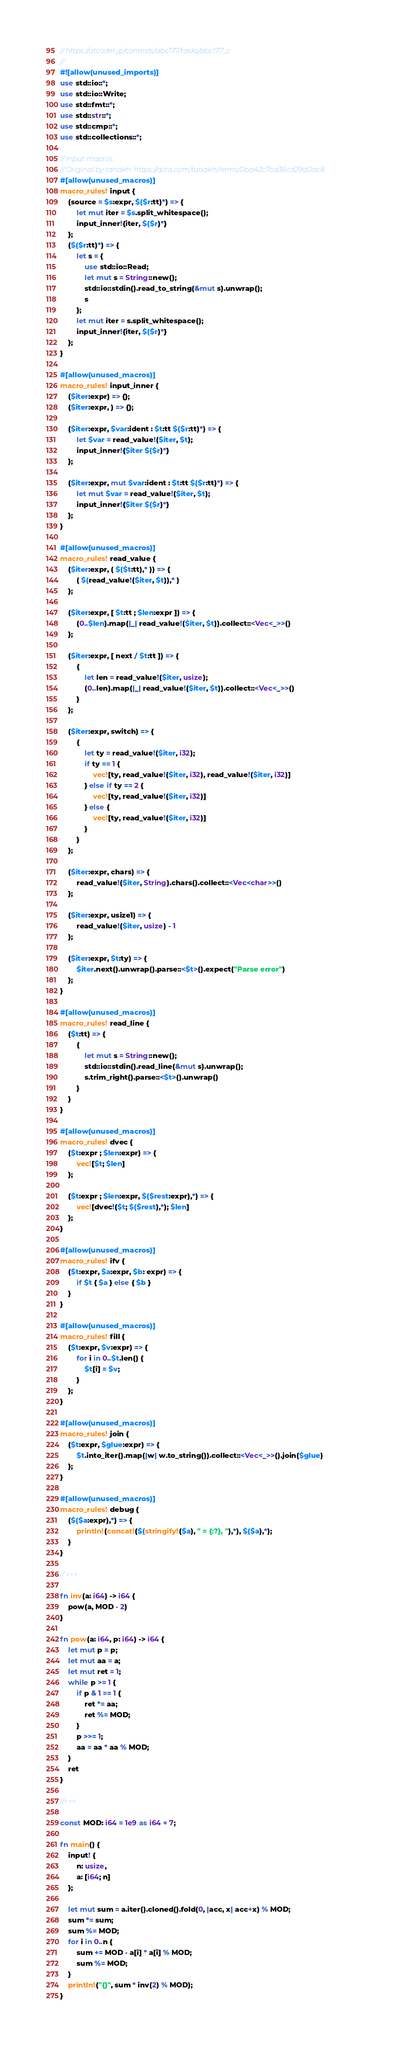Convert code to text. <code><loc_0><loc_0><loc_500><loc_500><_Rust_>// https://atcoder.jp/contests/abc177/tasks/abc177_c
//
#![allow(unused_imports)]
use std::io::*;
use std::io::Write;
use std::fmt::*;
use std::str::*;
use std::cmp::*;
use std::collections::*;

// Input macros.
// Original by tanakh: https://qiita.com/tanakh/items/0ba42c7ca36cd29d0ac8
#[allow(unused_macros)]
macro_rules! input {
    (source = $s:expr, $($r:tt)*) => {
        let mut iter = $s.split_whitespace();
        input_inner!{iter, $($r)*}
    };
    ($($r:tt)*) => {
        let s = {
            use std::io::Read;
            let mut s = String::new();
            std::io::stdin().read_to_string(&mut s).unwrap();
            s
        };
        let mut iter = s.split_whitespace();
        input_inner!{iter, $($r)*}
    };
}

#[allow(unused_macros)]
macro_rules! input_inner {
    ($iter:expr) => {};
    ($iter:expr, ) => {};

    ($iter:expr, $var:ident : $t:tt $($r:tt)*) => {
        let $var = read_value!($iter, $t);
        input_inner!{$iter $($r)*}
    };

    ($iter:expr, mut $var:ident : $t:tt $($r:tt)*) => {
        let mut $var = read_value!($iter, $t);
        input_inner!{$iter $($r)*}
    };
}

#[allow(unused_macros)]
macro_rules! read_value {
    ($iter:expr, ( $($t:tt),* )) => {
        ( $(read_value!($iter, $t)),* )
    };

    ($iter:expr, [ $t:tt ; $len:expr ]) => {
        (0..$len).map(|_| read_value!($iter, $t)).collect::<Vec<_>>()
    };

    ($iter:expr, [ next / $t:tt ]) => {
        {
            let len = read_value!($iter, usize);
            (0..len).map(|_| read_value!($iter, $t)).collect::<Vec<_>>()
        }
    };

    ($iter:expr, switch) => {
        {
            let ty = read_value!($iter, i32);
            if ty == 1 {
                vec![ty, read_value!($iter, i32), read_value!($iter, i32)]
            } else if ty == 2 {
                vec![ty, read_value!($iter, i32)]
            } else {
                vec![ty, read_value!($iter, i32)]
            }
        }
    };

    ($iter:expr, chars) => {
        read_value!($iter, String).chars().collect::<Vec<char>>()
    };

    ($iter:expr, usize1) => {
        read_value!($iter, usize) - 1
    };

    ($iter:expr, $t:ty) => {
        $iter.next().unwrap().parse::<$t>().expect("Parse error")
    };
}

#[allow(unused_macros)]
macro_rules! read_line {
    ($t:tt) => {
        {
            let mut s = String::new();
            std::io::stdin().read_line(&mut s).unwrap();
            s.trim_right().parse::<$t>().unwrap()
        }
    }
}

#[allow(unused_macros)]
macro_rules! dvec {
    ($t:expr ; $len:expr) => {
        vec![$t; $len]
    };

    ($t:expr ; $len:expr, $($rest:expr),*) => {
        vec![dvec!($t; $($rest),*); $len]
    };
}

#[allow(unused_macros)]
macro_rules! ifv {
    ($t:expr, $a:expr, $b: expr) => {
        if $t { $a } else { $b }
    }
}

#[allow(unused_macros)]
macro_rules! fill {
    ($t:expr, $v:expr) => {
        for i in 0..$t.len() {
            $t[i] = $v;
        }
    };
}

#[allow(unused_macros)]
macro_rules! join {
    ($t:expr, $glue:expr) => {
        $t.into_iter().map(|w| w.to_string()).collect::<Vec<_>>().join($glue)
    };
}

#[allow(unused_macros)]
macro_rules! debug {
    ($($a:expr),*) => {
        println!(concat!($(stringify!($a), " = {:?}, "),*), $($a),*);
    }
}

// ===

fn inv(a: i64) -> i64 {
    pow(a, MOD - 2)
}

fn pow(a: i64, p: i64) -> i64 {
    let mut p = p;
    let mut aa = a;
    let mut ret = 1;
    while p >= 1 {
        if p & 1 == 1 {
            ret *= aa;
            ret %= MOD;
        }
        p >>= 1;
        aa = aa * aa % MOD;
    }
    ret
}

//===

const MOD: i64 = 1e9 as i64 + 7;

fn main() {
    input! {
        n: usize,
        a: [i64; n]
    };

    let mut sum = a.iter().cloned().fold(0, |acc, x| acc+x) % MOD;
    sum *= sum;
    sum %= MOD;
    for i in 0..n {
        sum += MOD - a[i] * a[i] % MOD;
        sum %= MOD;
    }
    println!("{}", sum * inv(2) % MOD);
}
</code> 